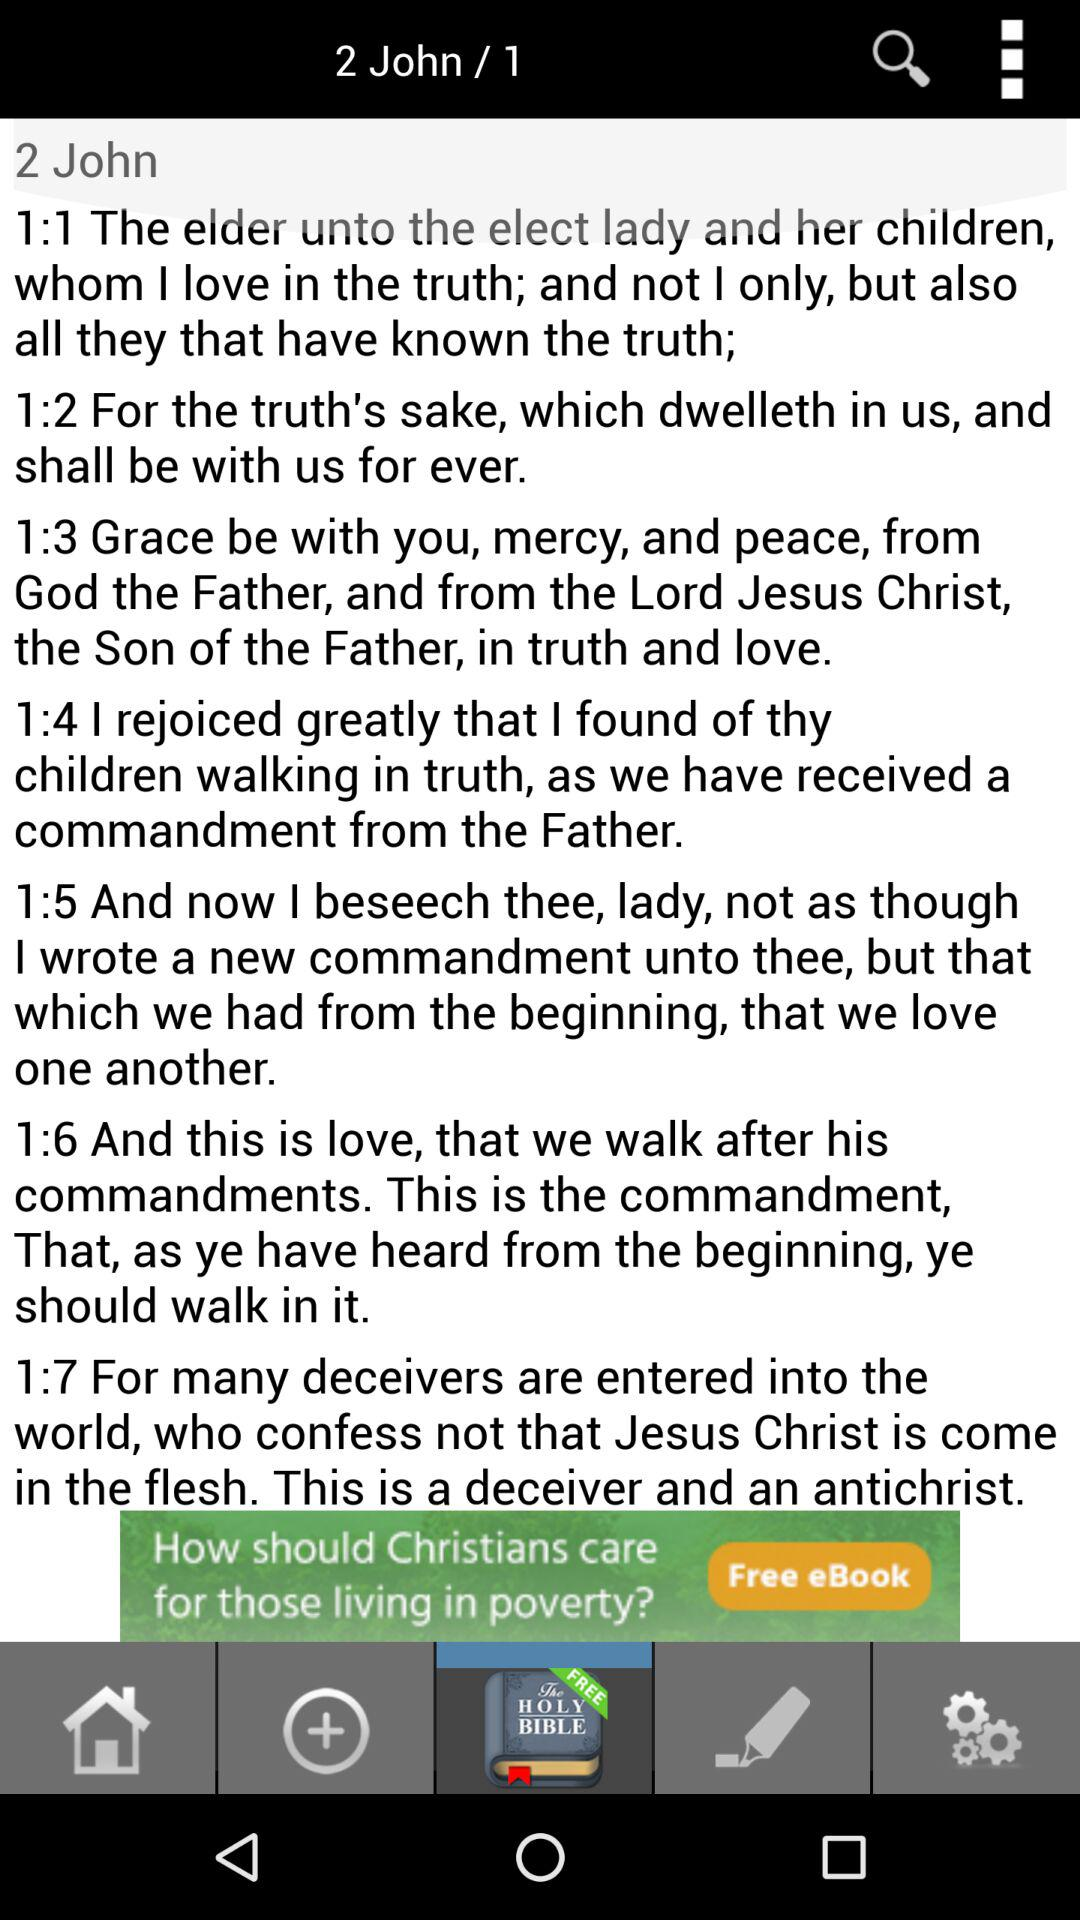How many verses are in chapter 1 of 2 John?
Answer the question using a single word or phrase. 7 